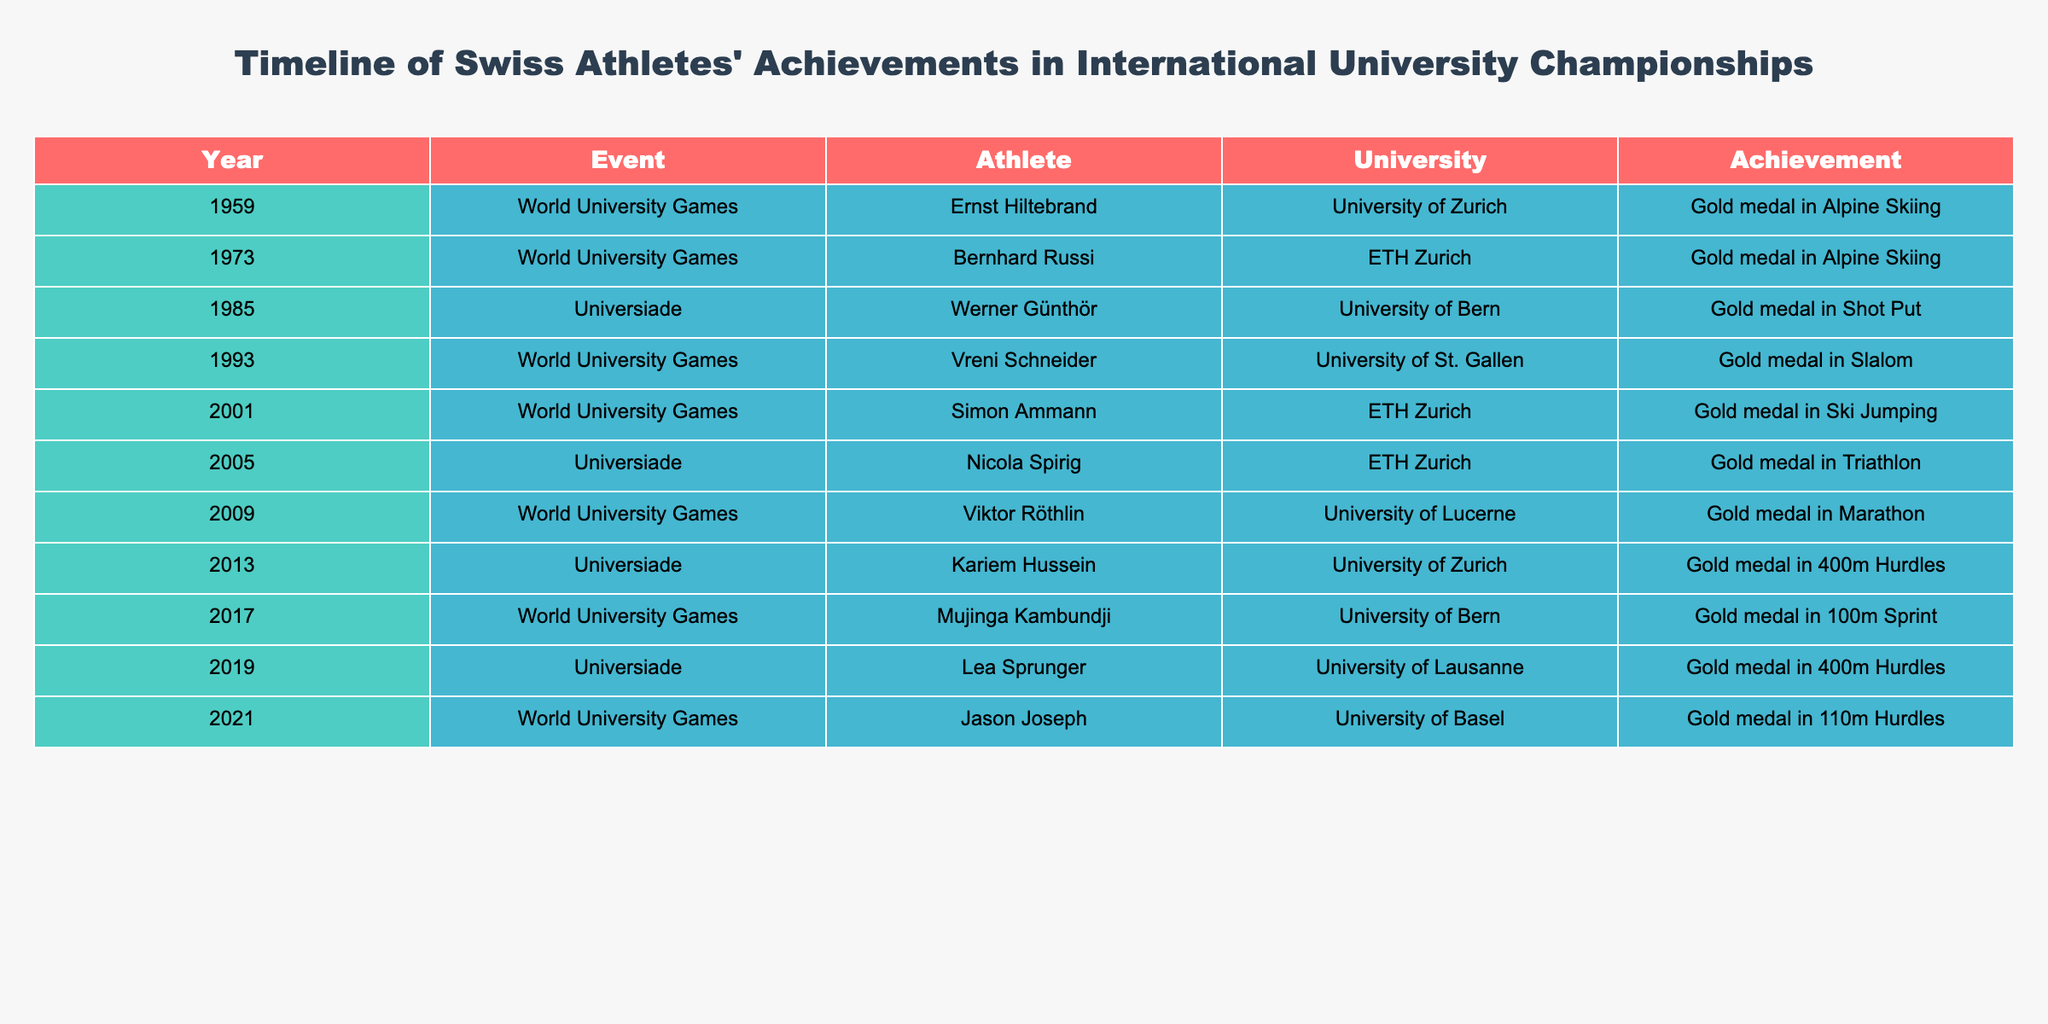What year did Nicola Spirig win gold in Triathlon? The table shows that Nicola Spirig won the gold medal in Triathlon in 2005 under the Universiade event.
Answer: 2005 Which athlete won a gold medal in 400m hurdles and from which university? The table indicates that both Kariem Hussein and Lea Sprunger won gold medals in the 400m hurdles, with Kariem representing the University of Zurich in 2013 and Lea representing the University of Lausanne in 2019.
Answer: Kariem Hussein, University of Zurich How many gold medals in skiing were won by Swiss athletes? From the table, Ernst Hiltebrand and Bernhard Russi both won gold medals in Alpine Skiing in 1959 and 1973, respectively. Additionally, Simon Ammann won a gold medal in Ski Jumping in 2001. Therefore, there are a total of three skiing gold medals.
Answer: 3 Did any athlete win a gold medal in Marathon? The table shows that Viktor Röthlin won a gold medal in Marathon in 2009. Therefore, the answer is yes.
Answer: Yes Which university had the most represented athletes in the gold medal list? By reviewing the table, it can be seen that ETH Zurich has three athletes: Bernhard Russi, Simon Ammann, and Nicola Spirig, while both the University of Zurich and the University of Bern have two each. Therefore, ETH Zurich is the university with the most represented athletes.
Answer: ETH Zurich What is the chronological sequence of events from 1959 to 2021? Analyzing the table, the sequence of events is: 1959 (World University Games, Ernst Hiltebrand), 1973 (World University Games, Bernhard Russi), 1985 (Universiade, Werner Günthör), 1993 (World University Games, Vreni Schneider), 2001 (World University Games, Simon Ammann), 2005 (Universiade, Nicola Spirig), 2009 (World University Games, Viktor Röthlin), 2013 (Universiade, Kariem Hussein), 2017 (World University Games, Mujinga Kambundji), 2019 (Universiade, Lea Sprunger), and 2021 (World University Games, Jason Joseph).
Answer: Detailed chronology provided Which athlete has the most recent gold medal achievement and in what event? The most recent athlete in the table is Jason Joseph, who won a gold medal in the 110m hurdles during the World University Games in 2021.
Answer: Jason Joseph, 110m hurdles 